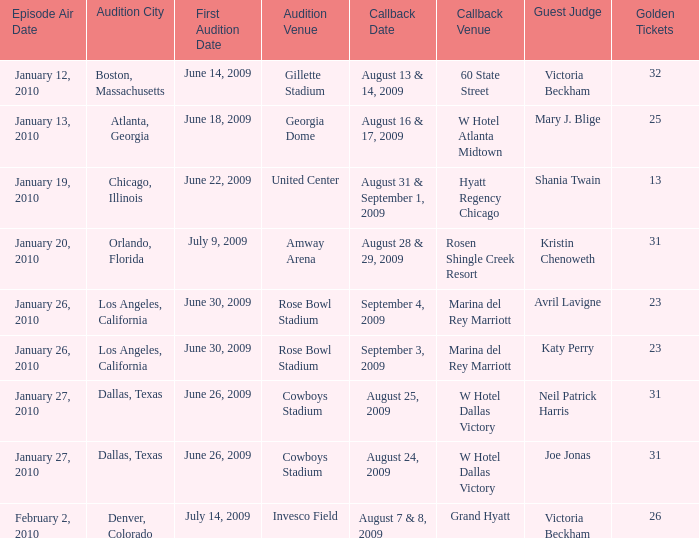What is the date for the callback event at amway arena? August 28 & 29, 2009. Could you parse the entire table? {'header': ['Episode Air Date', 'Audition City', 'First Audition Date', 'Audition Venue', 'Callback Date', 'Callback Venue', 'Guest Judge', 'Golden Tickets'], 'rows': [['January 12, 2010', 'Boston, Massachusetts', 'June 14, 2009', 'Gillette Stadium', 'August 13 & 14, 2009', '60 State Street', 'Victoria Beckham', '32'], ['January 13, 2010', 'Atlanta, Georgia', 'June 18, 2009', 'Georgia Dome', 'August 16 & 17, 2009', 'W Hotel Atlanta Midtown', 'Mary J. Blige', '25'], ['January 19, 2010', 'Chicago, Illinois', 'June 22, 2009', 'United Center', 'August 31 & September 1, 2009', 'Hyatt Regency Chicago', 'Shania Twain', '13'], ['January 20, 2010', 'Orlando, Florida', 'July 9, 2009', 'Amway Arena', 'August 28 & 29, 2009', 'Rosen Shingle Creek Resort', 'Kristin Chenoweth', '31'], ['January 26, 2010', 'Los Angeles, California', 'June 30, 2009', 'Rose Bowl Stadium', 'September 4, 2009', 'Marina del Rey Marriott', 'Avril Lavigne', '23'], ['January 26, 2010', 'Los Angeles, California', 'June 30, 2009', 'Rose Bowl Stadium', 'September 3, 2009', 'Marina del Rey Marriott', 'Katy Perry', '23'], ['January 27, 2010', 'Dallas, Texas', 'June 26, 2009', 'Cowboys Stadium', 'August 25, 2009', 'W Hotel Dallas Victory', 'Neil Patrick Harris', '31'], ['January 27, 2010', 'Dallas, Texas', 'June 26, 2009', 'Cowboys Stadium', 'August 24, 2009', 'W Hotel Dallas Victory', 'Joe Jonas', '31'], ['February 2, 2010', 'Denver, Colorado', 'July 14, 2009', 'Invesco Field', 'August 7 & 8, 2009', 'Grand Hyatt', 'Victoria Beckham', '26']]} 